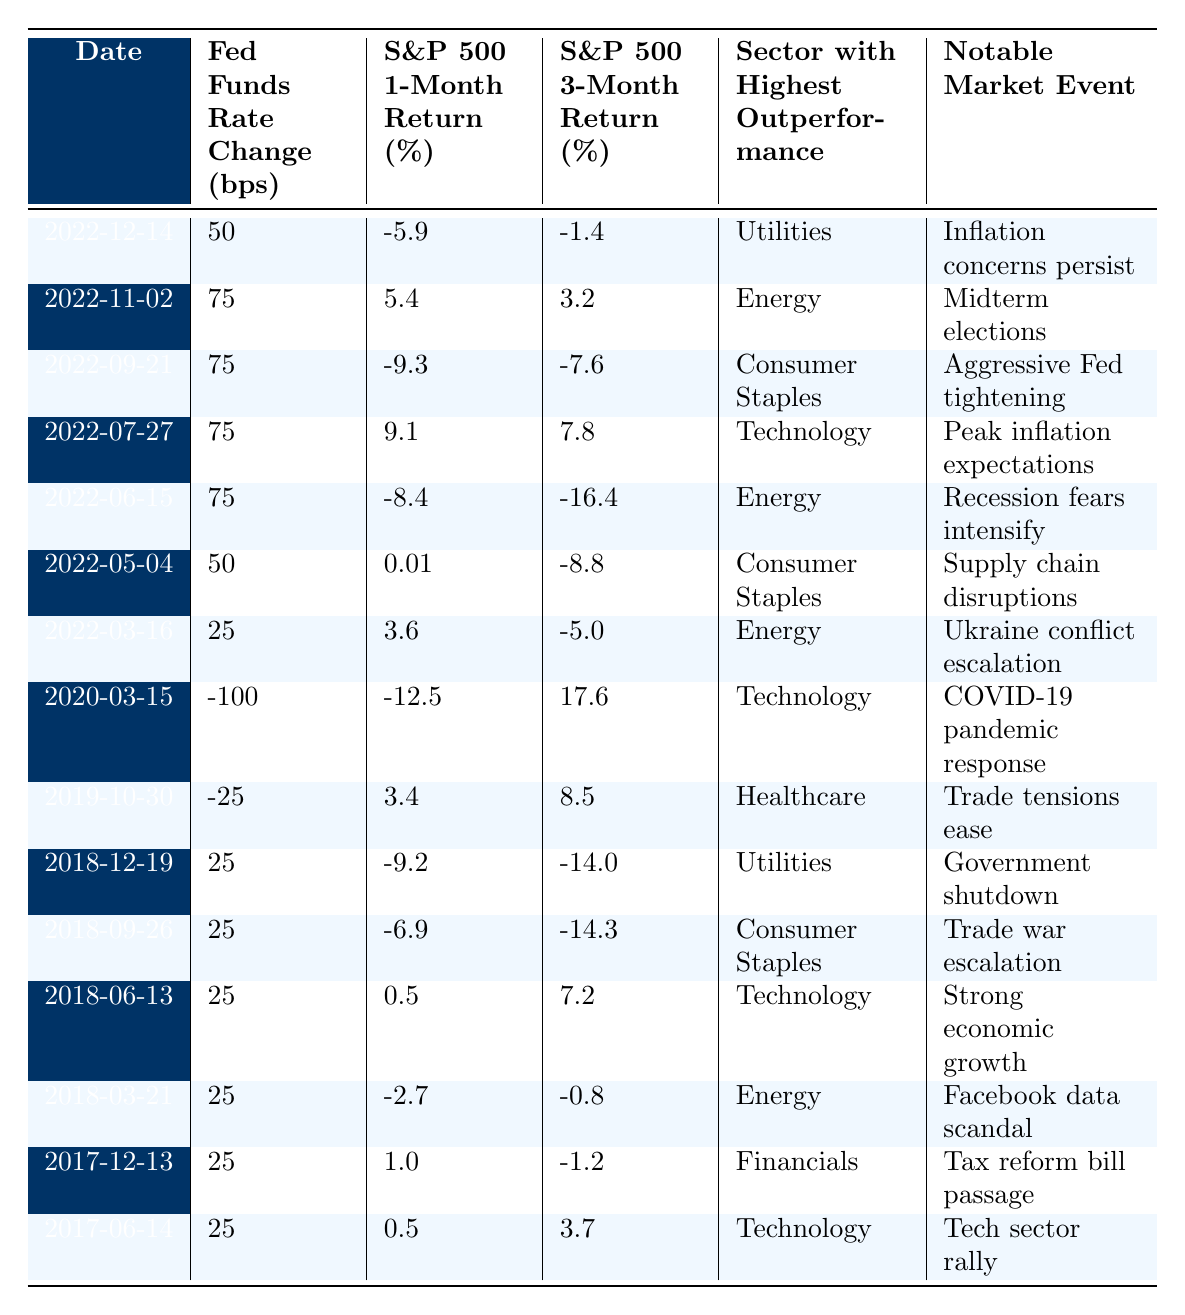What was the largest Federal Funds Rate change recorded in the table? The largest Federal Funds Rate change in the table is -100 basis points, which occurred on 2020-03-15.
Answer: -100 What was the S&P 500 3-month return on 2022-11-02? On 2022-11-02, the S&P 500 3-month return was 3.2%.
Answer: 3.2% Which sector outperformed the rest on 2022-07-27? On 2022-07-27, the sector with the highest outperformance was Technology.
Answer: Technology How did the S&P 500 perform 1-month after the Fed cut rates by 100 bps on 2020-03-15? After the rate cut of 100 bps, the S&P 500 had a 1-month return of -12.5%.
Answer: -12.5 What was the average S&P 500 1-month return across all entries? To calculate the average, sum the values of the S&P 500 1-month return (adding all the returns) = (-5.9 + 5.4 - 9.3 + 9.1 - 8.4 + 0.01 + 3.6 - 12.5 + 3.4 - 9.2 - 6.9 + 0.5 - 2.7 + 1.0 + 0.5) = -10.76. There are 15 entries, so the average = -10.76 / 15 ≈ -0.717.
Answer: -0.717 Is it true that the S&P 500 had a negative 3-month return after every rate increase shown in the table? This statement is false; there is a rate increase on 2022-07-27 with a 3-month return of 7.8%.
Answer: No What was the trend in the S&P 500 1-month returns surrounding the 2020 Fed rate cut? The S&P 500 1-month returns show a significant drop of -12.5% after the -100 bps cut, contrasting with a recovery of 17.6% over the following 3 months, indicating a rebound effect following the severe initial reaction.
Answer: Significant drop Which sector consistently outperformed across rate changes in 2022? The Agriculture and Consumer Staples sectors frequently appear but the only consistent outperformance occurred in the Technology sector on 2022-07-27 with a 9.1% return and on 2022-03-16 with a 3.6% return, indicating variance rather than consistency.
Answer: Not consistent 